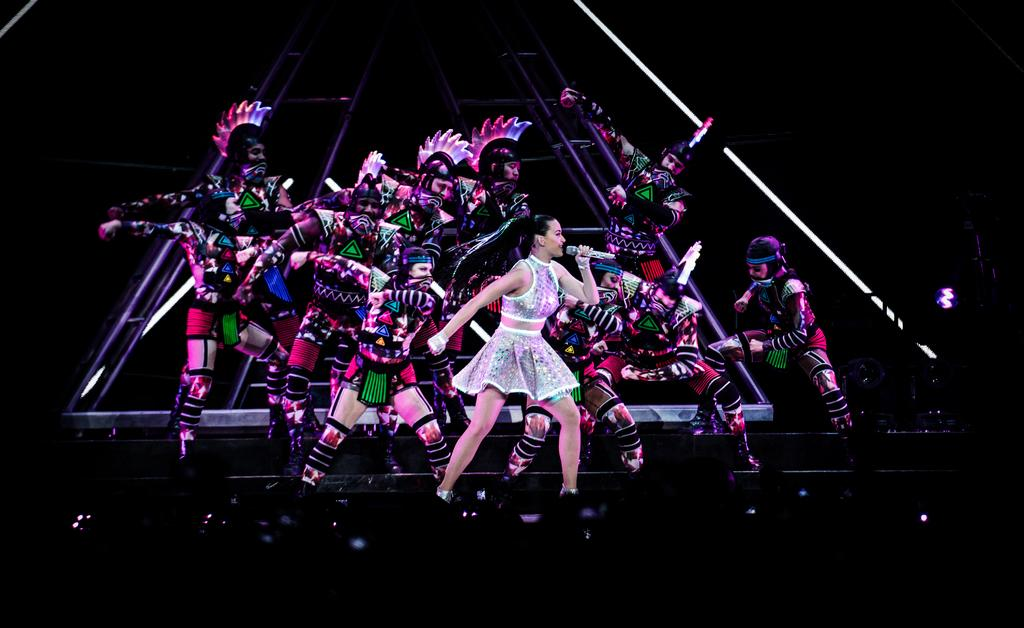What are the people in the image doing? A: The people in the image are dancing. Can you describe the woman in the image? There is a woman standing in front of the group, and she is holding a microphone. What type of measure is the woman using to weigh the turkey in the image? There is no measure or turkey present in the image. What kind of robin can be seen singing in the image? There is no robin present in the image. 